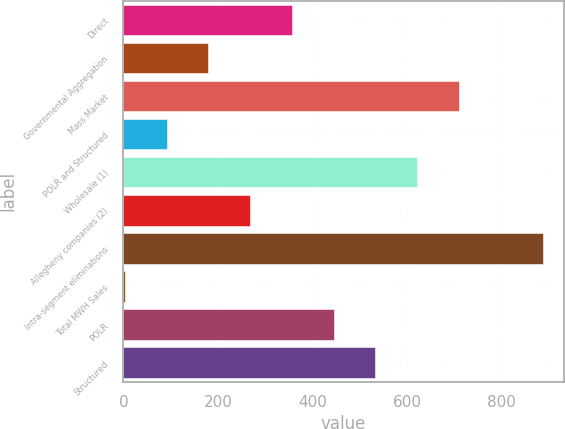<chart> <loc_0><loc_0><loc_500><loc_500><bar_chart><fcel>Direct<fcel>Governmental Aggregation<fcel>Mass Market<fcel>POLR and Structured<fcel>Wholesale (1)<fcel>Allegheny companies (2)<fcel>Intra-segment eliminations<fcel>Total MWH Sales<fcel>POLR<fcel>Structured<nl><fcel>356.4<fcel>179.6<fcel>710<fcel>91.2<fcel>621.6<fcel>268<fcel>886.8<fcel>2.8<fcel>444.8<fcel>533.2<nl></chart> 